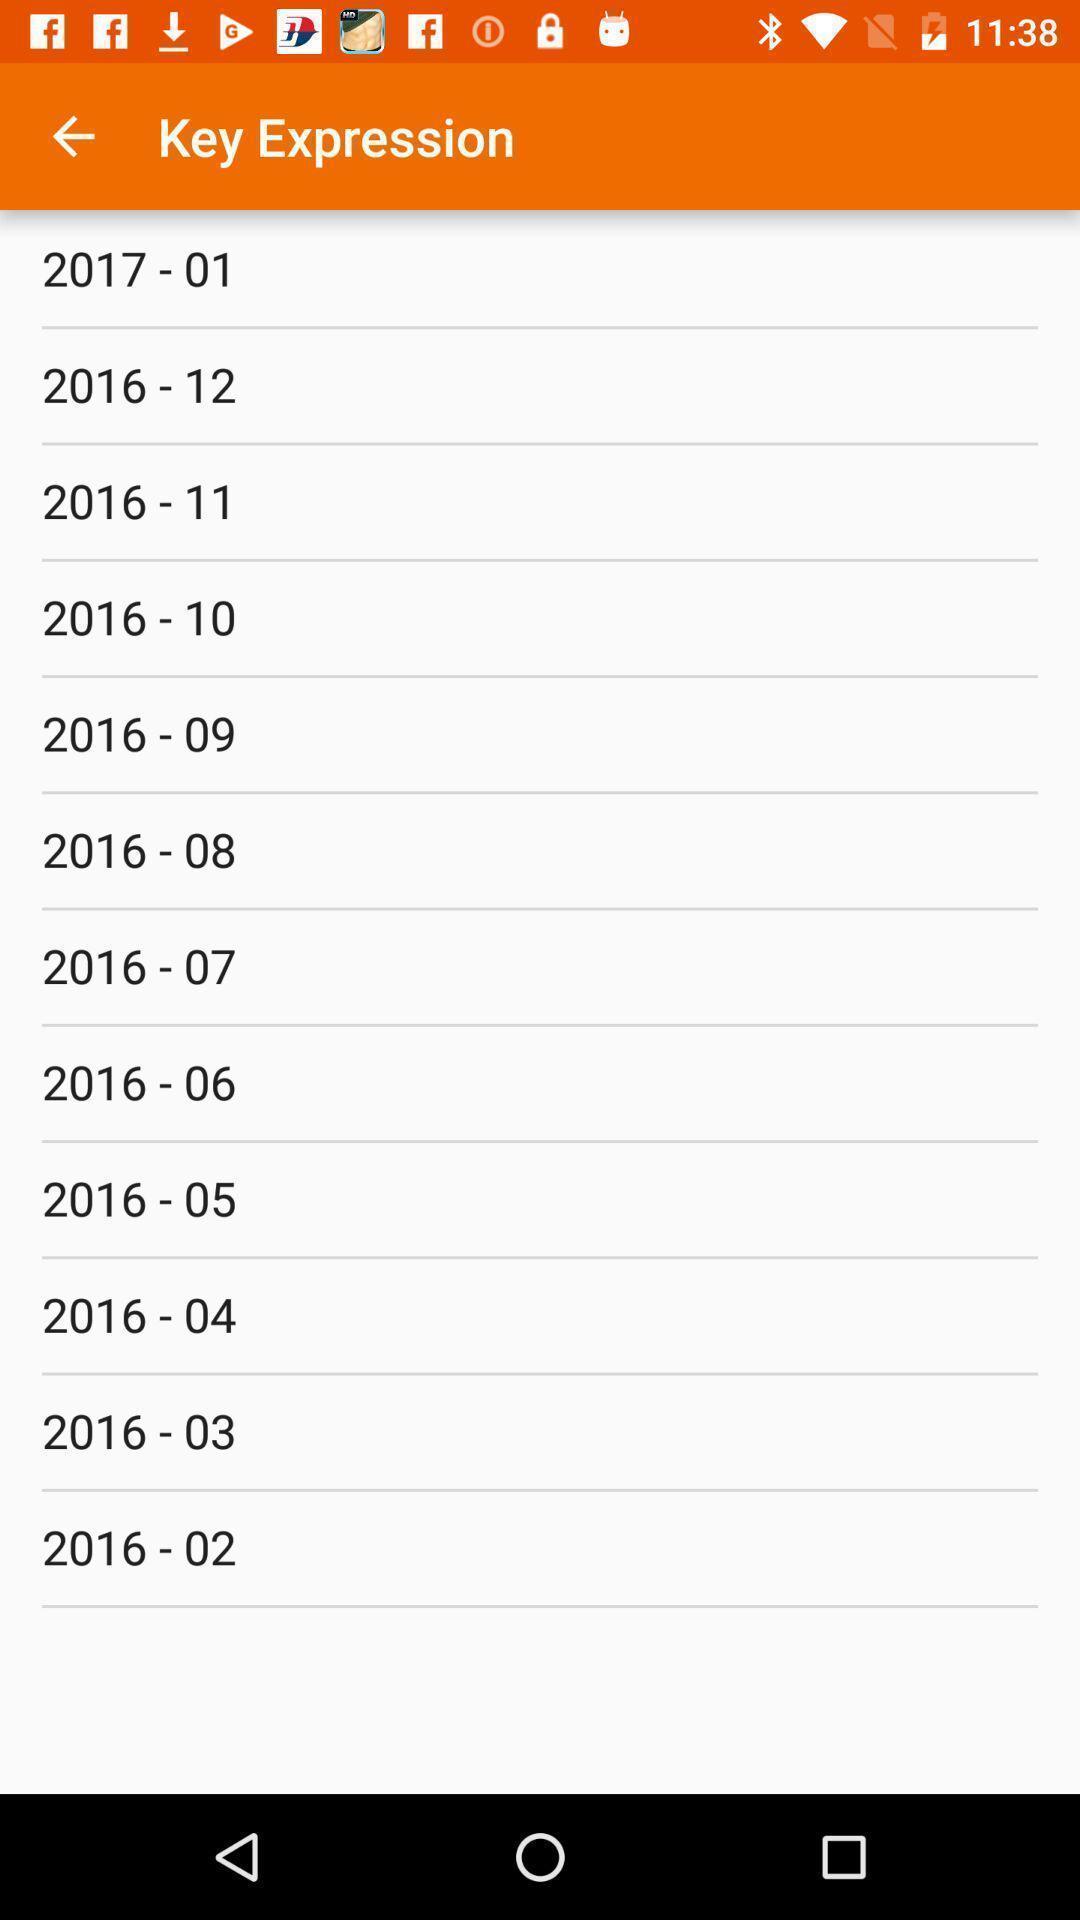Give me a summary of this screen capture. Page displaying various years. Summarize the main components in this picture. Page shows the key expression. 